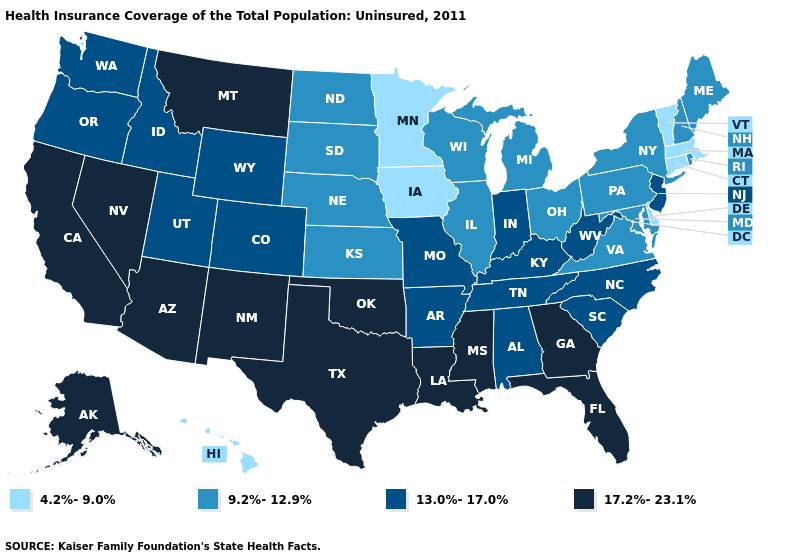What is the highest value in the West ?
Answer briefly. 17.2%-23.1%. Which states hav the highest value in the Northeast?
Keep it brief. New Jersey. What is the highest value in states that border Oklahoma?
Be succinct. 17.2%-23.1%. Among the states that border Georgia , which have the lowest value?
Quick response, please. Alabama, North Carolina, South Carolina, Tennessee. What is the lowest value in the South?
Quick response, please. 4.2%-9.0%. What is the lowest value in the USA?
Short answer required. 4.2%-9.0%. Name the states that have a value in the range 17.2%-23.1%?
Quick response, please. Alaska, Arizona, California, Florida, Georgia, Louisiana, Mississippi, Montana, Nevada, New Mexico, Oklahoma, Texas. Name the states that have a value in the range 4.2%-9.0%?
Write a very short answer. Connecticut, Delaware, Hawaii, Iowa, Massachusetts, Minnesota, Vermont. Does Hawaii have the lowest value in the USA?
Give a very brief answer. Yes. Which states hav the highest value in the MidWest?
Short answer required. Indiana, Missouri. What is the lowest value in the USA?
Quick response, please. 4.2%-9.0%. What is the lowest value in states that border Wisconsin?
Short answer required. 4.2%-9.0%. What is the value of Indiana?
Concise answer only. 13.0%-17.0%. Name the states that have a value in the range 17.2%-23.1%?
Keep it brief. Alaska, Arizona, California, Florida, Georgia, Louisiana, Mississippi, Montana, Nevada, New Mexico, Oklahoma, Texas. 